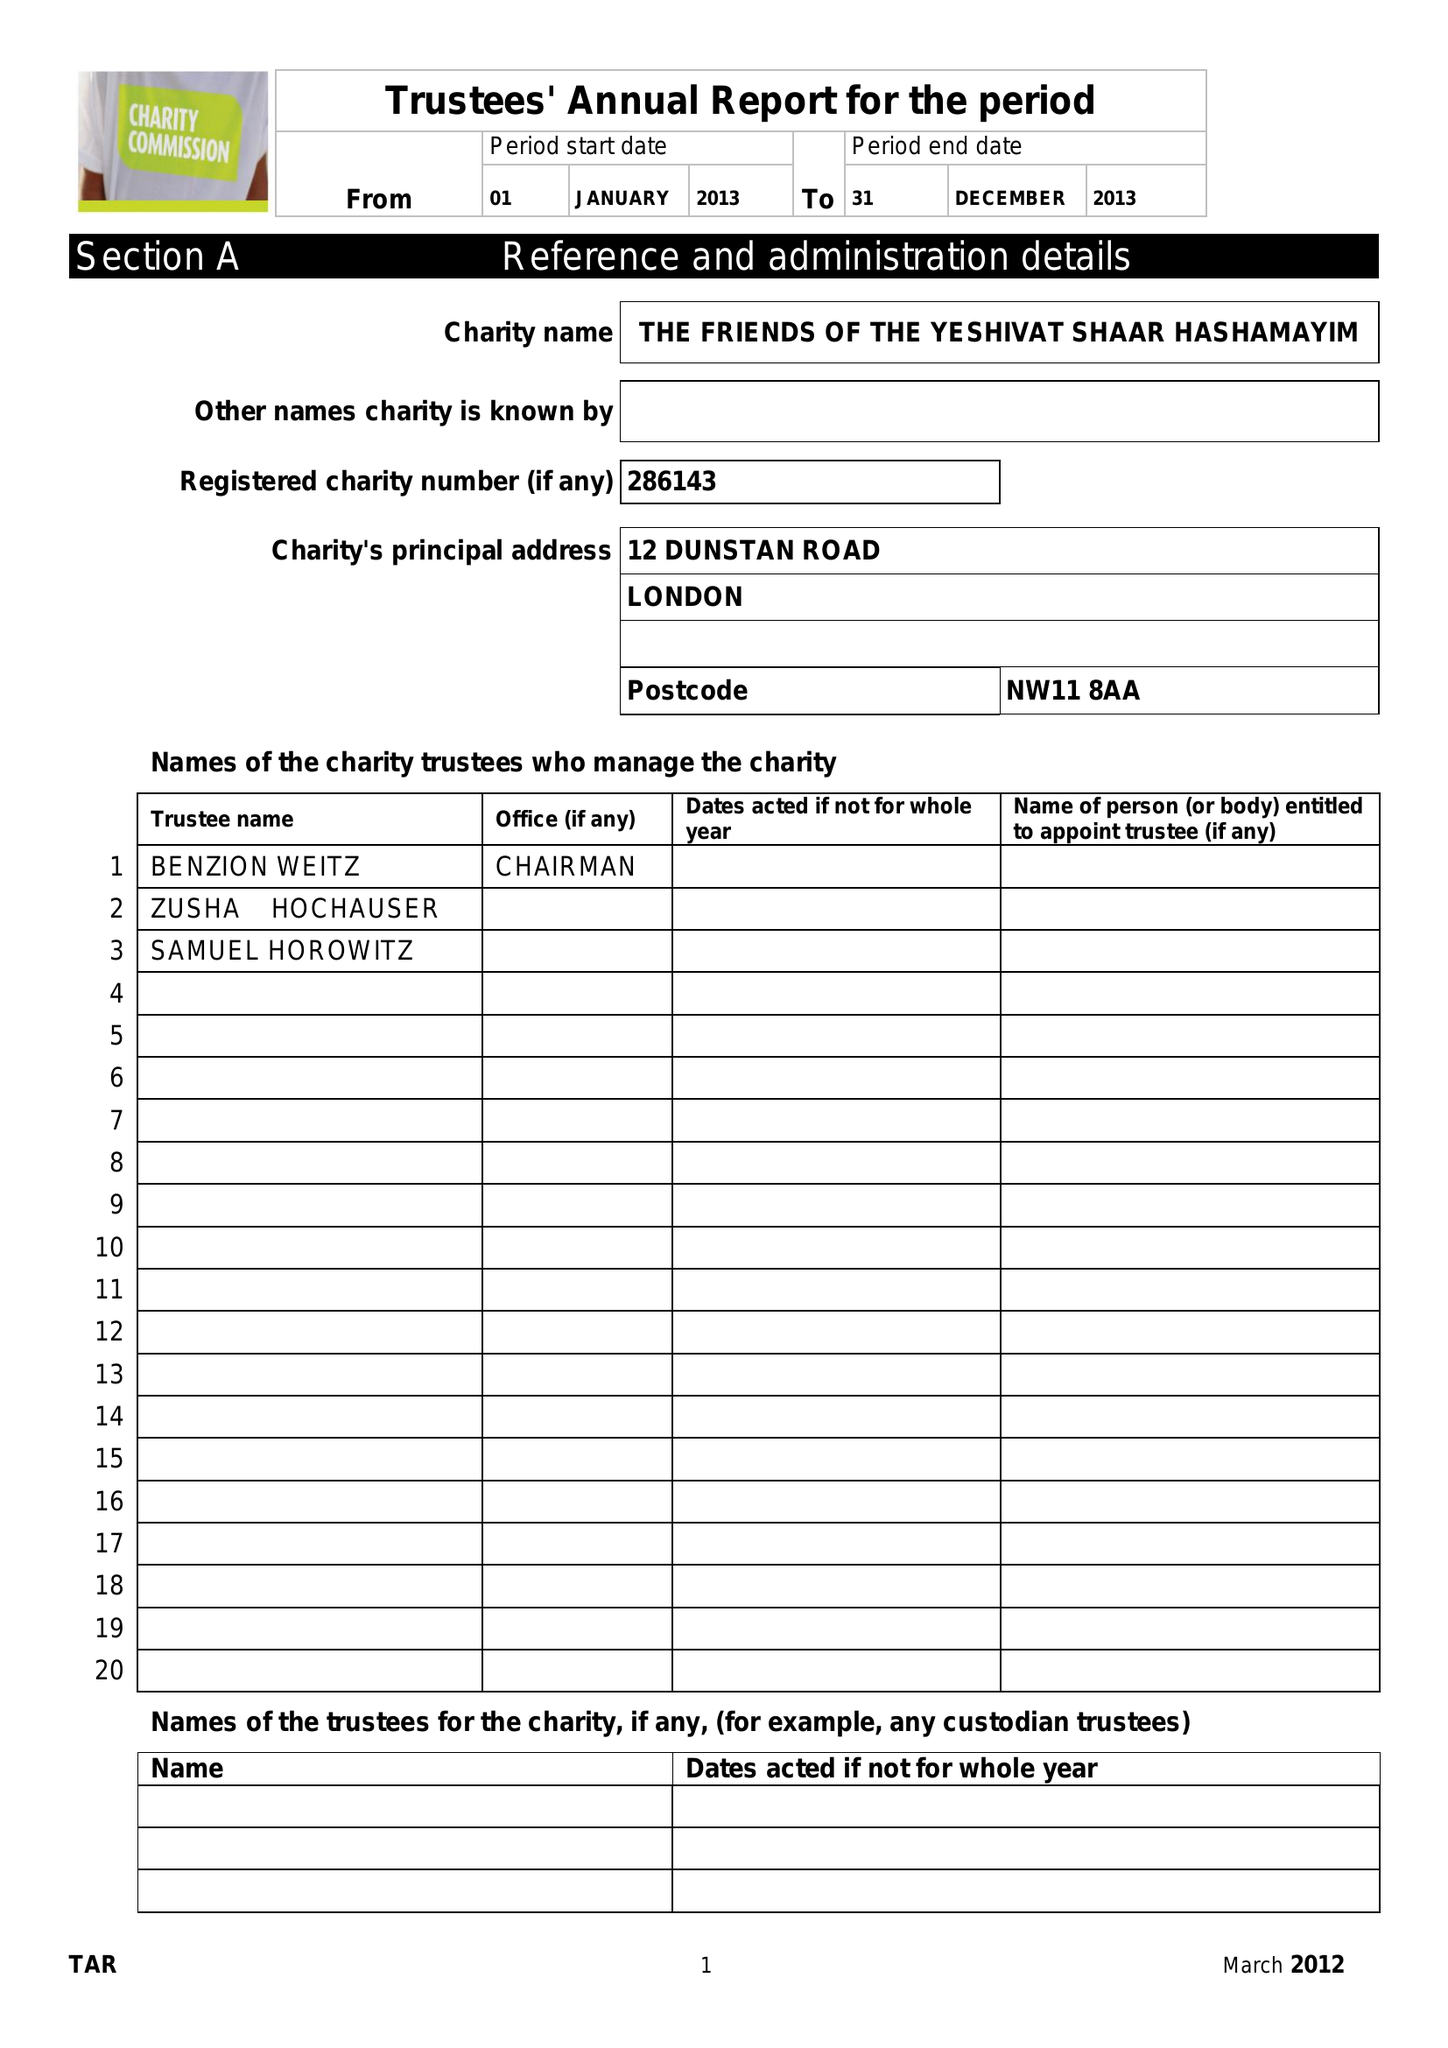What is the value for the report_date?
Answer the question using a single word or phrase. 2013-12-31 